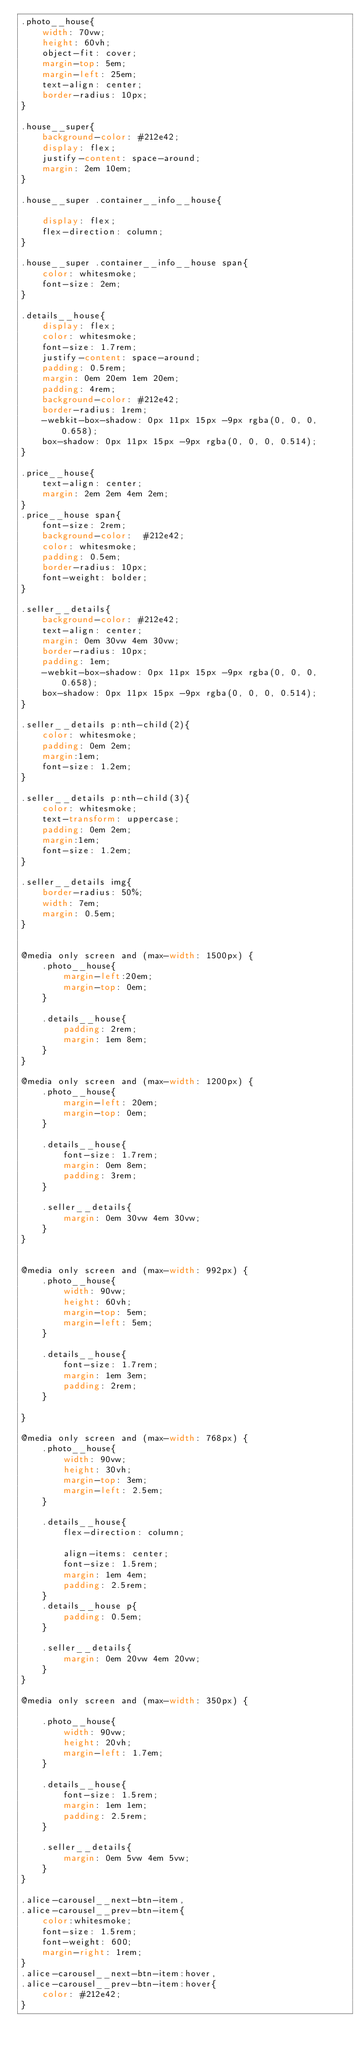<code> <loc_0><loc_0><loc_500><loc_500><_CSS_>.photo__house{
    width: 70vw;
    height: 60vh;
    object-fit: cover;
    margin-top: 5em;
    margin-left: 25em;
    text-align: center;
    border-radius: 10px;
}

.house__super{
    background-color: #212e42;
    display: flex;
    justify-content: space-around;
    margin: 2em 10em;
}

.house__super .container__info__house{
    
    display: flex;
    flex-direction: column;
}

.house__super .container__info__house span{
    color: whitesmoke;
    font-size: 2em;
}

.details__house{
    display: flex;
    color: whitesmoke;
    font-size: 1.7rem;
    justify-content: space-around;
    padding: 0.5rem;
    margin: 0em 20em 1em 20em;
    padding: 4rem;
    background-color: #212e42;
    border-radius: 1rem;
    -webkit-box-shadow: 0px 11px 15px -9px rgba(0, 0, 0, 0.658);
    box-shadow: 0px 11px 15px -9px rgba(0, 0, 0, 0.514);
}

.price__house{
    text-align: center;
    margin: 2em 2em 4em 2em;
}
.price__house span{
    font-size: 2rem;
    background-color:  #212e42;
    color: whitesmoke;
    padding: 0.5em;
    border-radius: 10px;
    font-weight: bolder;
}

.seller__details{
    background-color: #212e42;
    text-align: center;
    margin: 0em 30vw 4em 30vw;
    border-radius: 10px;
    padding: 1em;
    -webkit-box-shadow: 0px 11px 15px -9px rgba(0, 0, 0, 0.658);
    box-shadow: 0px 11px 15px -9px rgba(0, 0, 0, 0.514);
}

.seller__details p:nth-child(2){
    color: whitesmoke;
    padding: 0em 2em;
    margin:1em;
    font-size: 1.2em;
}

.seller__details p:nth-child(3){
    color: whitesmoke;
    text-transform: uppercase;
    padding: 0em 2em;
    margin:1em;
    font-size: 1.2em;
}

.seller__details img{
    border-radius: 50%;
    width: 7em;
    margin: 0.5em;
} 


@media only screen and (max-width: 1500px) {
    .photo__house{
        margin-left:20em;
        margin-top: 0em;
    }

    .details__house{
        padding: 2rem;
        margin: 1em 8em;
    }
}

@media only screen and (max-width: 1200px) {
    .photo__house{
        margin-left: 20em;
        margin-top: 0em;
    }

    .details__house{
        font-size: 1.7rem;
        margin: 0em 8em;
        padding: 3rem;
    }

    .seller__details{
        margin: 0em 30vw 4em 30vw;
    }
}


@media only screen and (max-width: 992px) {
    .photo__house{
        width: 90vw;
        height: 60vh;
        margin-top: 5em;
        margin-left: 5em;
    }

    .details__house{
        font-size: 1.7rem;
        margin: 1em 3em;
        padding: 2rem;
    }
    
}

@media only screen and (max-width: 768px) {
    .photo__house{
        width: 90vw;
        height: 30vh;
        margin-top: 3em;
        margin-left: 2.5em;
    }

    .details__house{
        flex-direction: column;
      
        align-items: center;
        font-size: 1.5rem;
        margin: 1em 4em;
        padding: 2.5rem;
    }
    .details__house p{
        padding: 0.5em;
    }

    .seller__details{
        margin: 0em 20vw 4em 20vw;
    }
}

@media only screen and (max-width: 350px) {
    
    .photo__house{  
        width: 90vw;
        height: 20vh;
        margin-left: 1.7em;
    }

    .details__house{
        font-size: 1.5rem;
        margin: 1em 1em;
        padding: 2.5rem;
    }

    .seller__details{
        margin: 0em 5vw 4em 5vw;
    }
}

.alice-carousel__next-btn-item,
.alice-carousel__prev-btn-item{
    color:whitesmoke;
    font-size: 1.5rem;
    font-weight: 600;
    margin-right: 1rem;
}
.alice-carousel__next-btn-item:hover,
.alice-carousel__prev-btn-item:hover{
    color: #212e42;
}


</code> 